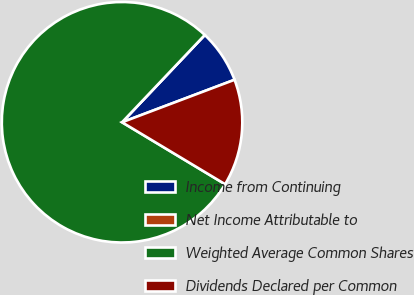Convert chart to OTSL. <chart><loc_0><loc_0><loc_500><loc_500><pie_chart><fcel>Income from Continuing<fcel>Net Income Attributable to<fcel>Weighted Average Common Shares<fcel>Dividends Declared per Common<nl><fcel>7.18%<fcel>0.0%<fcel>78.46%<fcel>14.36%<nl></chart> 